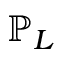<formula> <loc_0><loc_0><loc_500><loc_500>\mathbb { P } _ { L }</formula> 